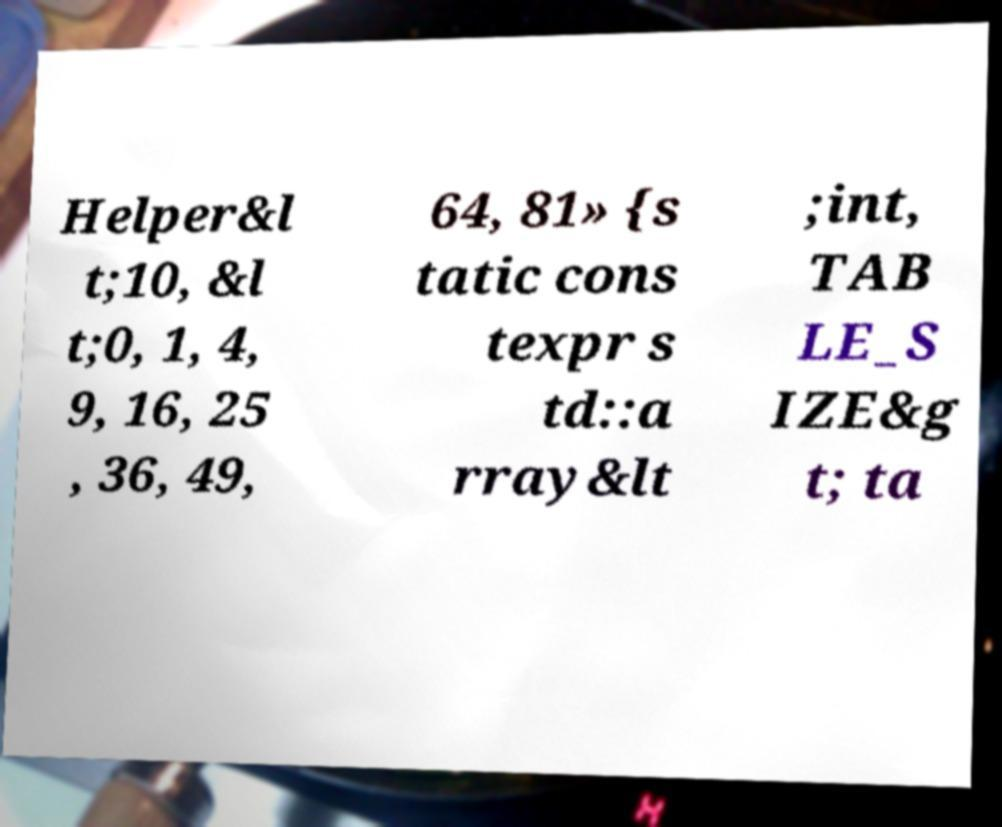Can you read and provide the text displayed in the image?This photo seems to have some interesting text. Can you extract and type it out for me? Helper&l t;10, &l t;0, 1, 4, 9, 16, 25 , 36, 49, 64, 81» {s tatic cons texpr s td::a rray&lt ;int, TAB LE_S IZE&g t; ta 